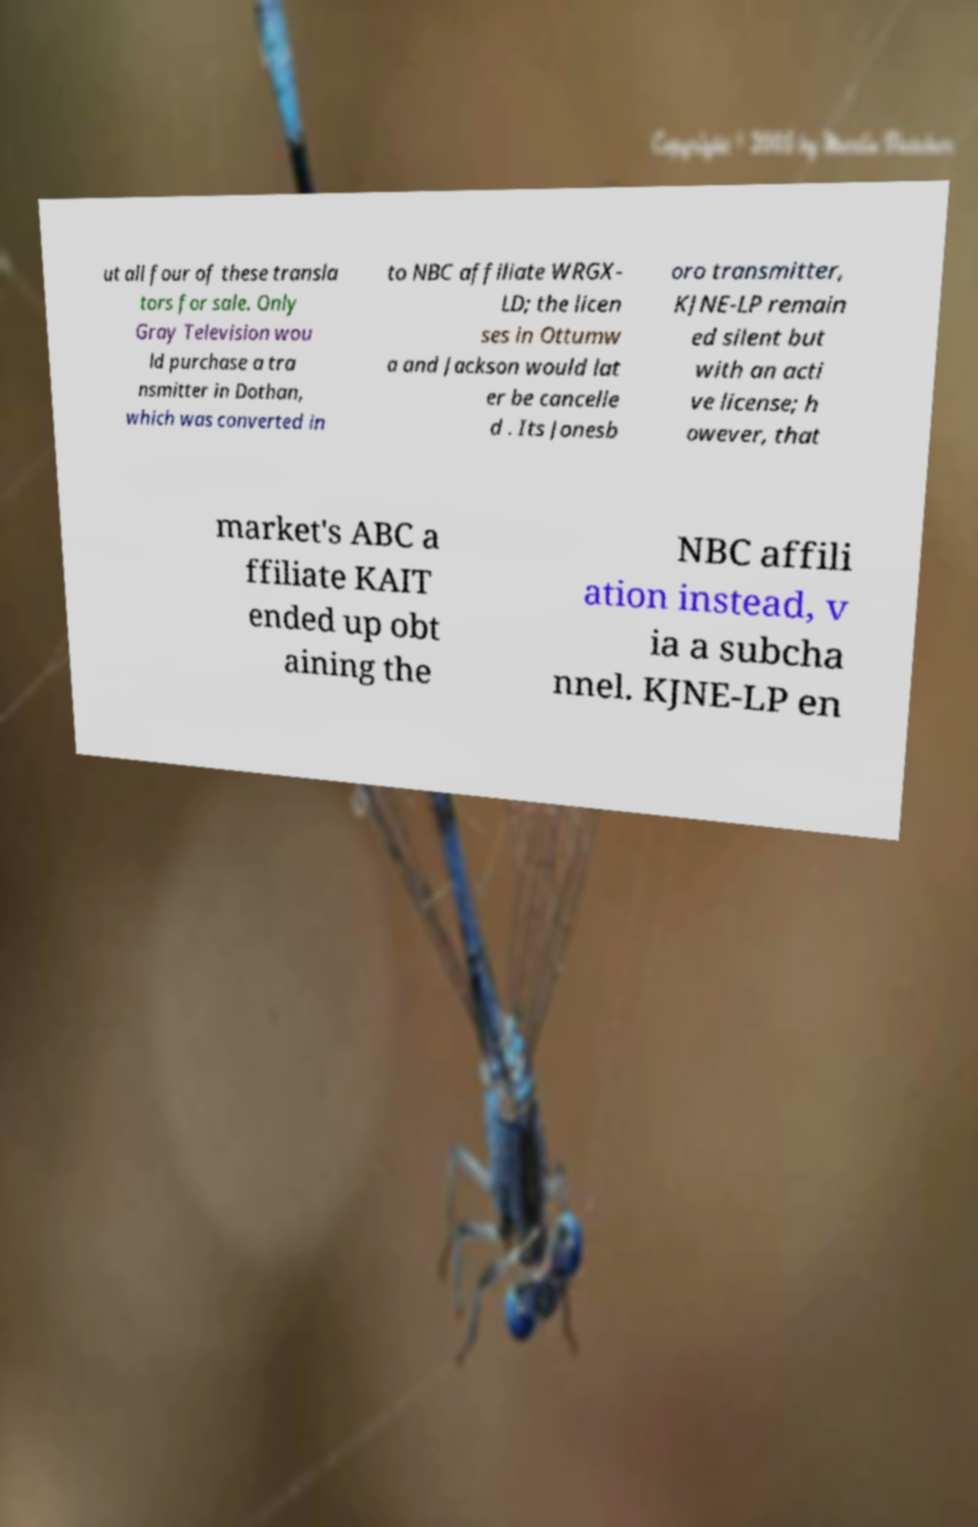Can you accurately transcribe the text from the provided image for me? ut all four of these transla tors for sale. Only Gray Television wou ld purchase a tra nsmitter in Dothan, which was converted in to NBC affiliate WRGX- LD; the licen ses in Ottumw a and Jackson would lat er be cancelle d . Its Jonesb oro transmitter, KJNE-LP remain ed silent but with an acti ve license; h owever, that market's ABC a ffiliate KAIT ended up obt aining the NBC affili ation instead, v ia a subcha nnel. KJNE-LP en 